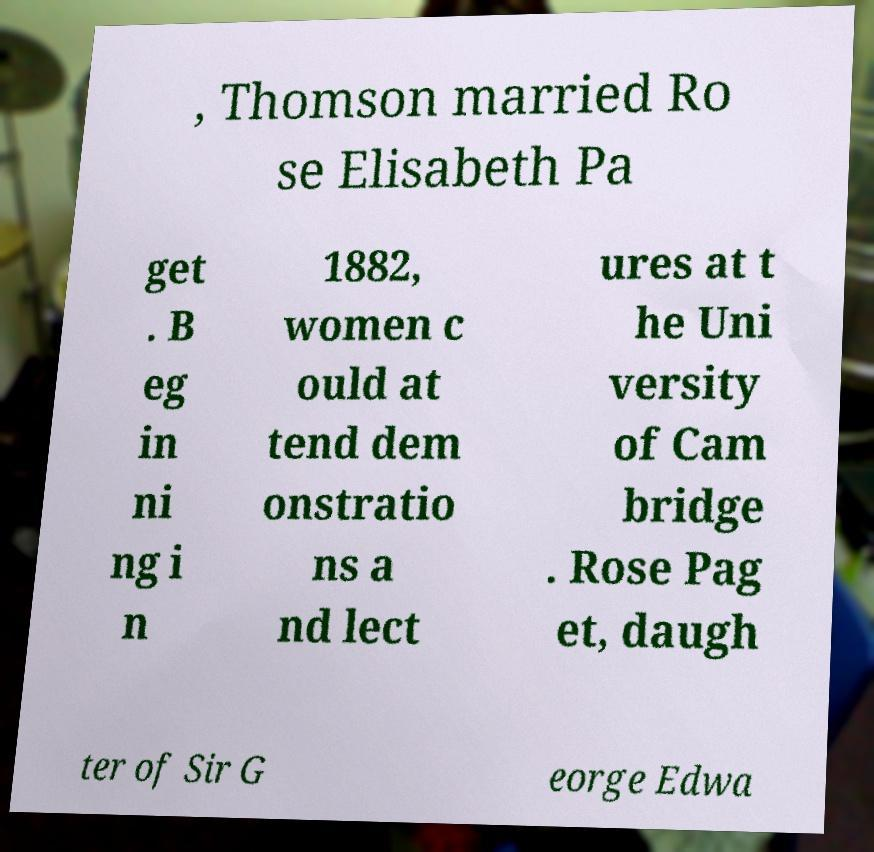There's text embedded in this image that I need extracted. Can you transcribe it verbatim? , Thomson married Ro se Elisabeth Pa get . B eg in ni ng i n 1882, women c ould at tend dem onstratio ns a nd lect ures at t he Uni versity of Cam bridge . Rose Pag et, daugh ter of Sir G eorge Edwa 